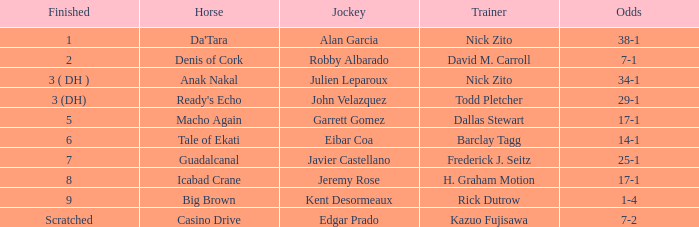Parse the table in full. {'header': ['Finished', 'Horse', 'Jockey', 'Trainer', 'Odds'], 'rows': [['1', "Da'Tara", 'Alan Garcia', 'Nick Zito', '38-1'], ['2', 'Denis of Cork', 'Robby Albarado', 'David M. Carroll', '7-1'], ['3 ( DH )', 'Anak Nakal', 'Julien Leparoux', 'Nick Zito', '34-1'], ['3 (DH)', "Ready's Echo", 'John Velazquez', 'Todd Pletcher', '29-1'], ['5', 'Macho Again', 'Garrett Gomez', 'Dallas Stewart', '17-1'], ['6', 'Tale of Ekati', 'Eibar Coa', 'Barclay Tagg', '14-1'], ['7', 'Guadalcanal', 'Javier Castellano', 'Frederick J. Seitz', '25-1'], ['8', 'Icabad Crane', 'Jeremy Rose', 'H. Graham Motion', '17-1'], ['9', 'Big Brown', 'Kent Desormeaux', 'Rick Dutrow', '1-4'], ['Scratched', 'Casino Drive', 'Edgar Prado', 'Kazuo Fujisawa', '7-2']]} Who is the Jockey that has Nick Zito as Trainer and Odds of 34-1? Julien Leparoux. 